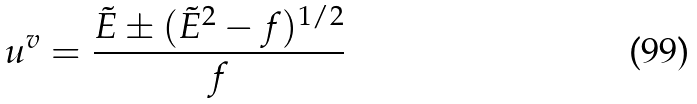Convert formula to latex. <formula><loc_0><loc_0><loc_500><loc_500>u ^ { v } = \frac { \tilde { E } \pm ( \tilde { E } ^ { 2 } - f ) ^ { 1 / 2 } } { f }</formula> 